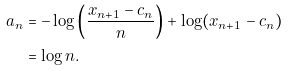Convert formula to latex. <formula><loc_0><loc_0><loc_500><loc_500>a _ { n } & = - \log \left ( \frac { x _ { n + 1 } - c _ { n } } { n } \right ) + \log ( x _ { n + 1 } - c _ { n } ) \\ & = \log n .</formula> 